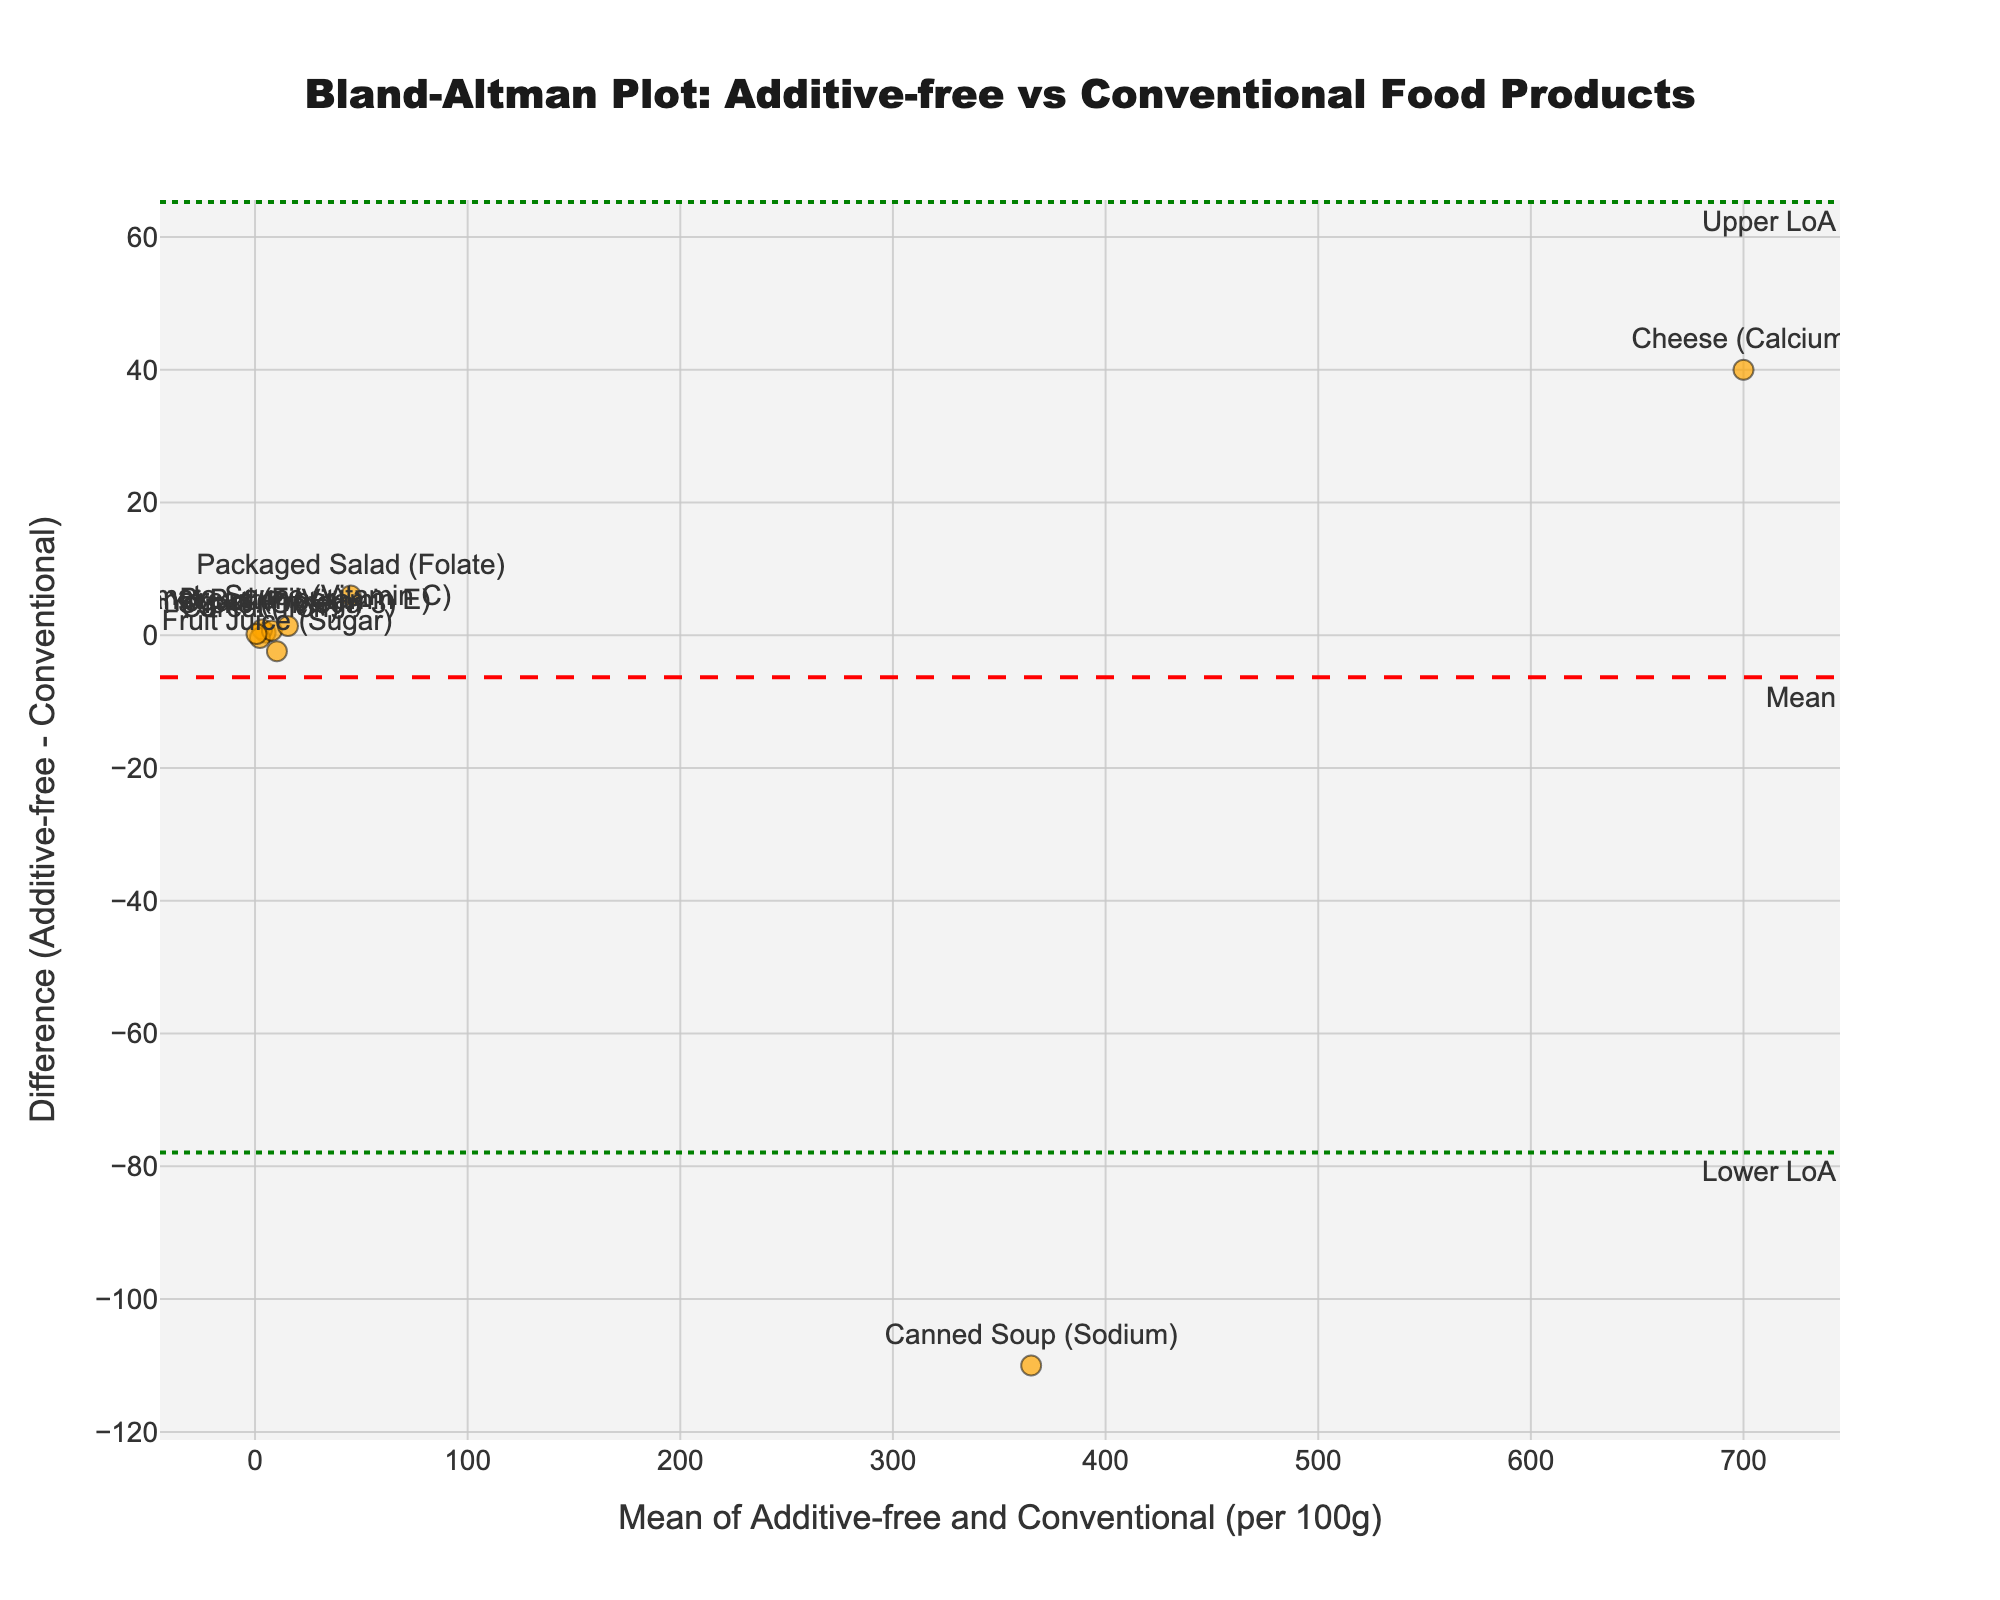What's the title of the plot? The title is usually located at the top of the plot and is meant to provide a quick description of what the plot represents. In this case, it reads "Bland-Altman Plot: Additive-free vs Conventional Food Products".
Answer: Bland-Altman Plot: Additive-free vs Conventional Food Products How many food categories are represented in the plot? Each data point represents a food category. By counting the number of data points, one can determine the number of food categories. Here, there are 10 data points.
Answer: 10 What is the mean difference (Additive-free - Conventional) shown in the plot? The mean difference is indicated by a dashed red line labeled "Mean". The value of this line represents the mean difference.
Answer: 0.95 Which food category has the largest positive difference between Additive-free and Conventional? To find the largest positive difference, look for the data point with the highest y-value. Here, "Packaged Salad (Folate)" has the highest positive difference.
Answer: Packaged Salad (Folate) What is the range of the limits of agreement in the plot? The limits of agreement are depicted by two dotted green lines labeled "Lower LoA" and "Upper LoA". These lines indicate the range of agreement.
Answer: -0.29 to 2.19 Which food category has the smallest mean value? To find the smallest mean value, look at the x-values of each data point and identify the lowest one. "Fish Sticks (Omega-3)" has the smallest mean value.
Answer: Fish Sticks (Omega-3) Do any food categories fall outside the limits of agreement? Check if any data points lie beyond the dotted green lines representing the limits of agreement. In this case, "Canned Soup (Sodium)" is outside the limits.
Answer: Yes, Canned Soup (Sodium) How does the difference for "Fruit Juice (Sugar)" compare to the mean difference? Compare the y-value of the "Fruit Juice (Sugar)" data point to the red dashed line representing the mean difference. "Fruit Juice (Sugar)" has a negative difference of -2.4, which is below the mean difference of 0.95.
Answer: Below Which food categories have a negative difference (Additive-free < Conventional)? Look for data points with a negative y-value. The food categories with negative differences are "Cereal (Iron)", "Fruit Juice (Sugar)", and "Canned Soup (Sodium)".
Answer: Cereal (Iron), Fruit Juice (Sugar), Canned Soup (Sodium) What is the average nutritional value for "Tomato Sauce (Vitamin C)" reported in the plot? The average value is depicted in the "hovertext" for each data point. For "Tomato Sauce (Vitamin C)", the average value is 15.5.
Answer: 15.5 